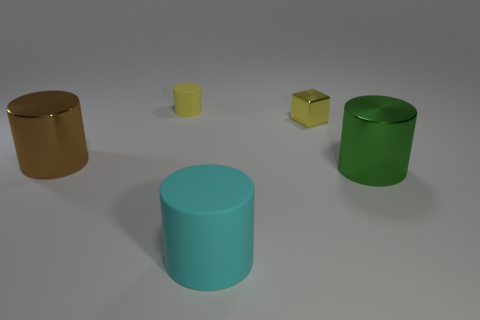Do the matte thing that is in front of the brown cylinder and the metal object that is behind the big brown metallic object have the same shape?
Your response must be concise. No. There is a big object that is on the left side of the cube and on the right side of the brown cylinder; what is its color?
Your answer should be compact. Cyan. There is a matte cylinder in front of the tiny rubber thing; is its size the same as the cylinder that is right of the tiny metallic thing?
Ensure brevity in your answer.  Yes. How many other blocks have the same color as the metallic cube?
Provide a succinct answer. 0. How many small objects are cubes or blue metal spheres?
Your answer should be compact. 1. Is the cylinder that is behind the tiny block made of the same material as the cyan thing?
Your answer should be compact. Yes. What color is the large cylinder to the left of the yellow matte cylinder?
Make the answer very short. Brown. Are there any cyan cylinders of the same size as the green thing?
Offer a terse response. Yes. There is a cyan cylinder that is the same size as the green cylinder; what is its material?
Your response must be concise. Rubber. Is the size of the yellow metallic cube the same as the cyan matte cylinder that is in front of the yellow rubber object?
Keep it short and to the point. No. 